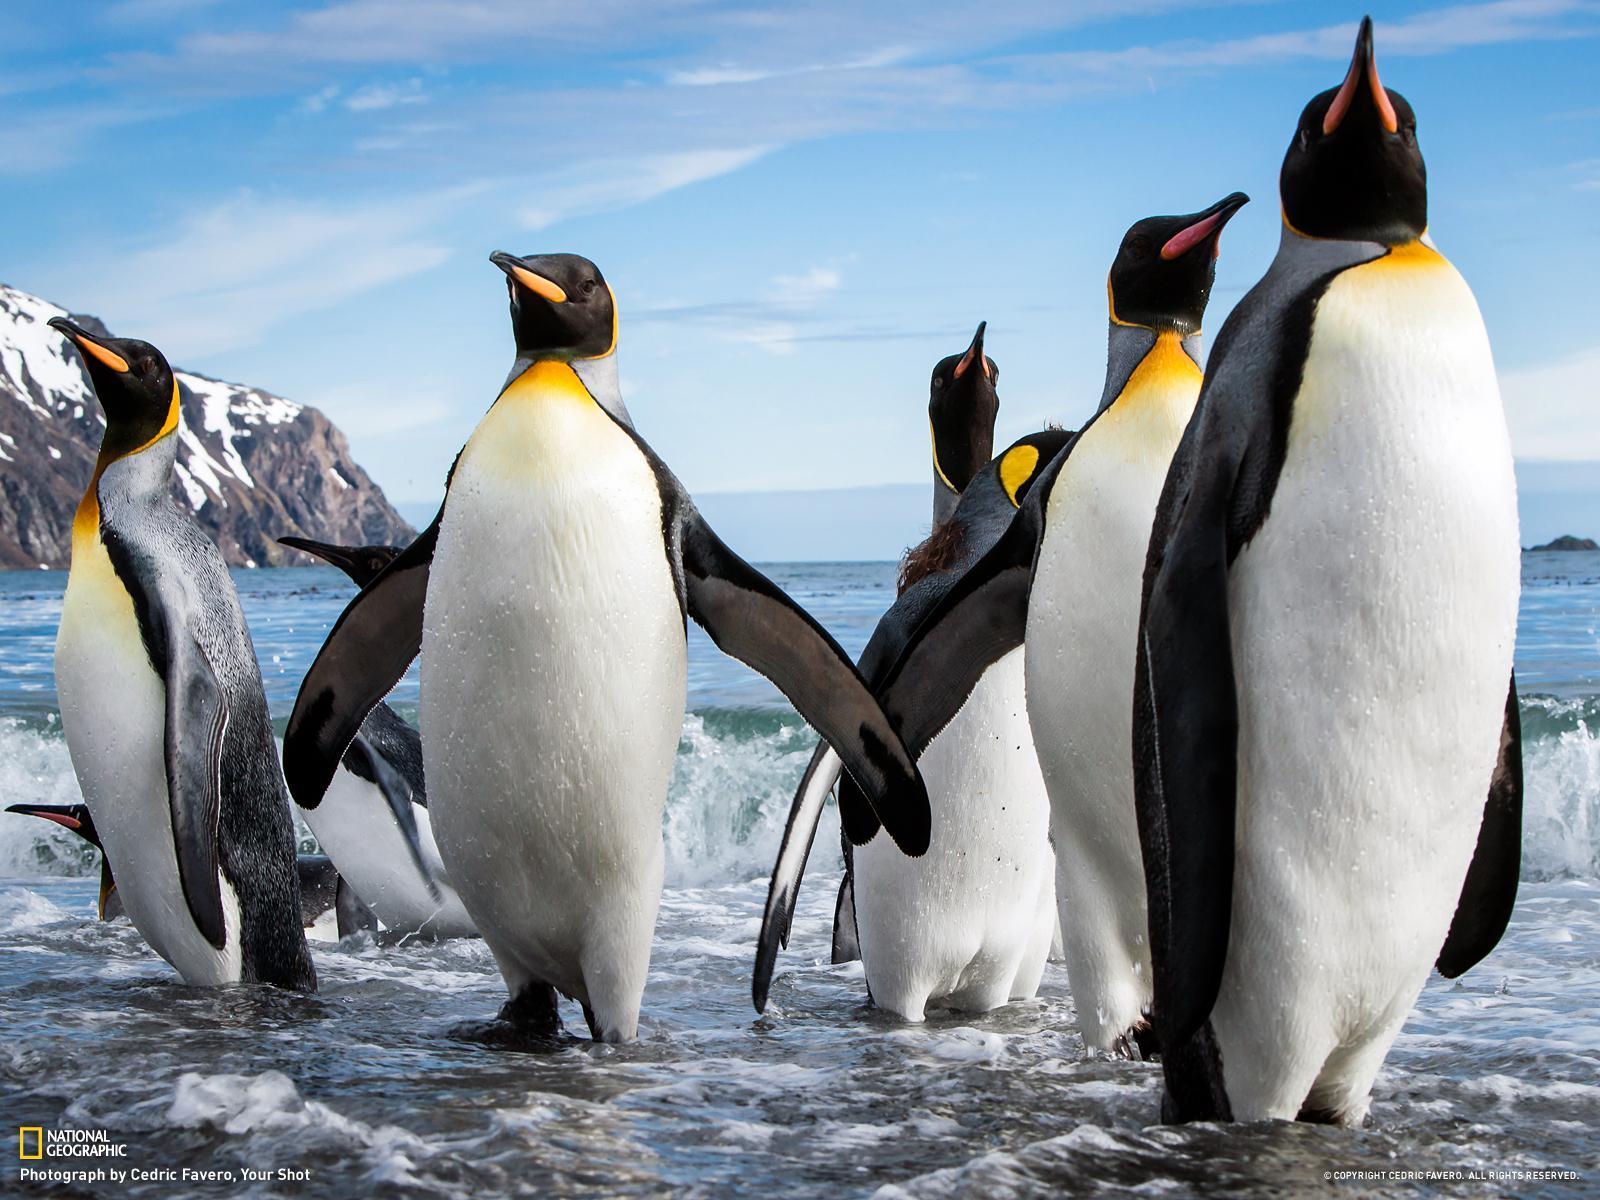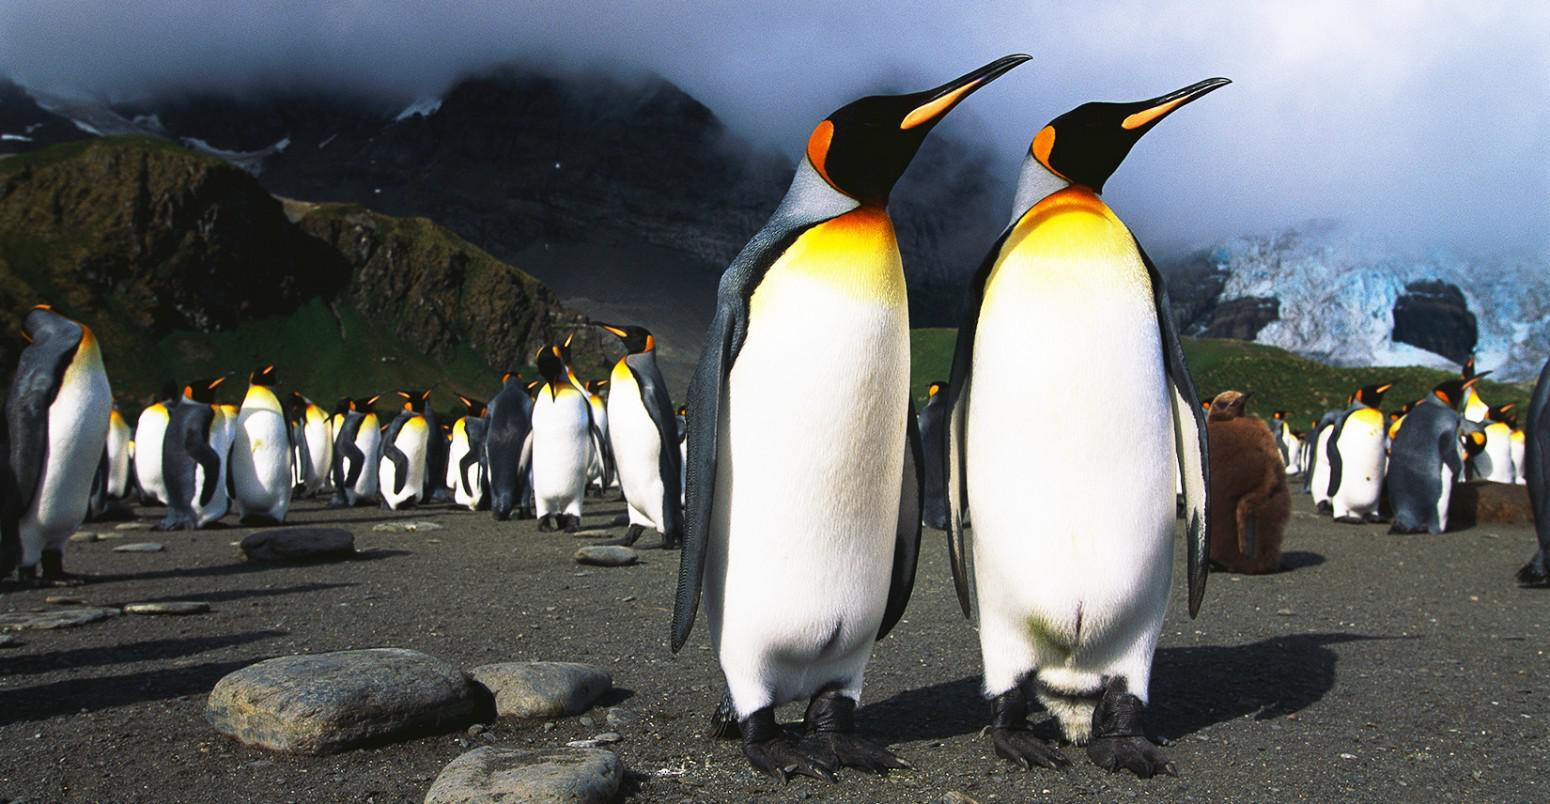The first image is the image on the left, the second image is the image on the right. Assess this claim about the two images: "The penguins in one image are in splashing water, while those in the other image are standing on solid, dry ground.". Correct or not? Answer yes or no. Yes. The first image is the image on the left, the second image is the image on the right. Analyze the images presented: Is the assertion "In one image the penguins are in the water" valid? Answer yes or no. Yes. The first image is the image on the left, the second image is the image on the right. Considering the images on both sides, is "The left image has no more than 4 penguins" valid? Answer yes or no. No. The first image is the image on the left, the second image is the image on the right. For the images displayed, is the sentence "A group of four penguins is walking together in the image on the right." factually correct? Answer yes or no. No. 